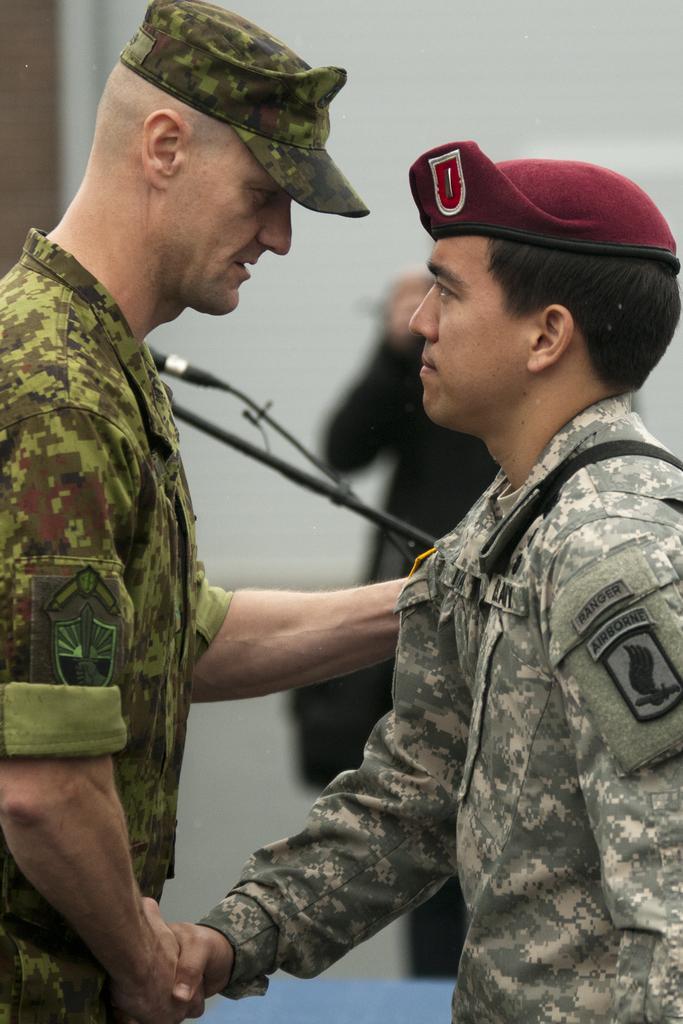Can you describe this image briefly? In the foreground of this picture we can see the two people standing, wearing uniforms and shaking their hands. In the background we can see the wall, a person like thing and a microphone attached to the metal stand. 